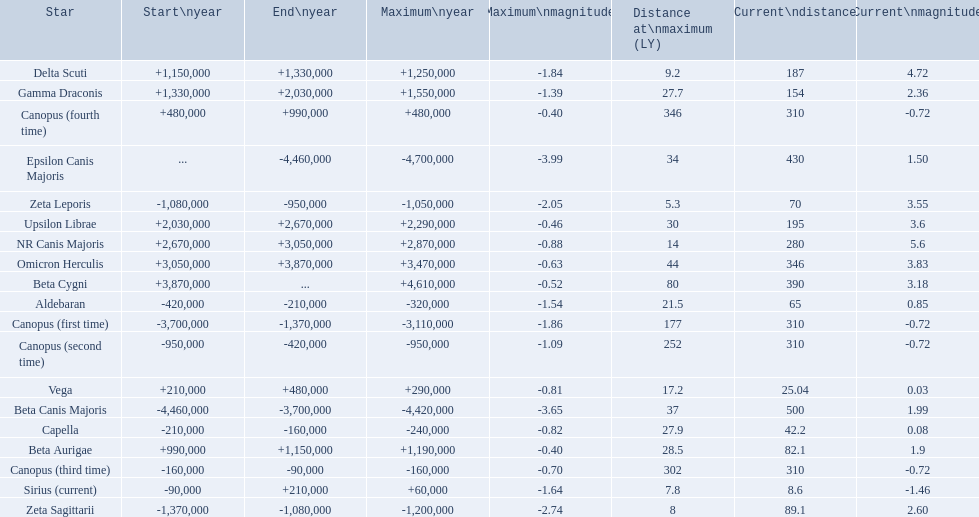What are the historical brightest stars? Epsilon Canis Majoris, Beta Canis Majoris, Canopus (first time), Zeta Sagittarii, Zeta Leporis, Canopus (second time), Aldebaran, Capella, Canopus (third time), Sirius (current), Vega, Canopus (fourth time), Beta Aurigae, Delta Scuti, Gamma Draconis, Upsilon Librae, NR Canis Majoris, Omicron Herculis, Beta Cygni. Of those which star has a distance at maximum of 80 Beta Cygni. 